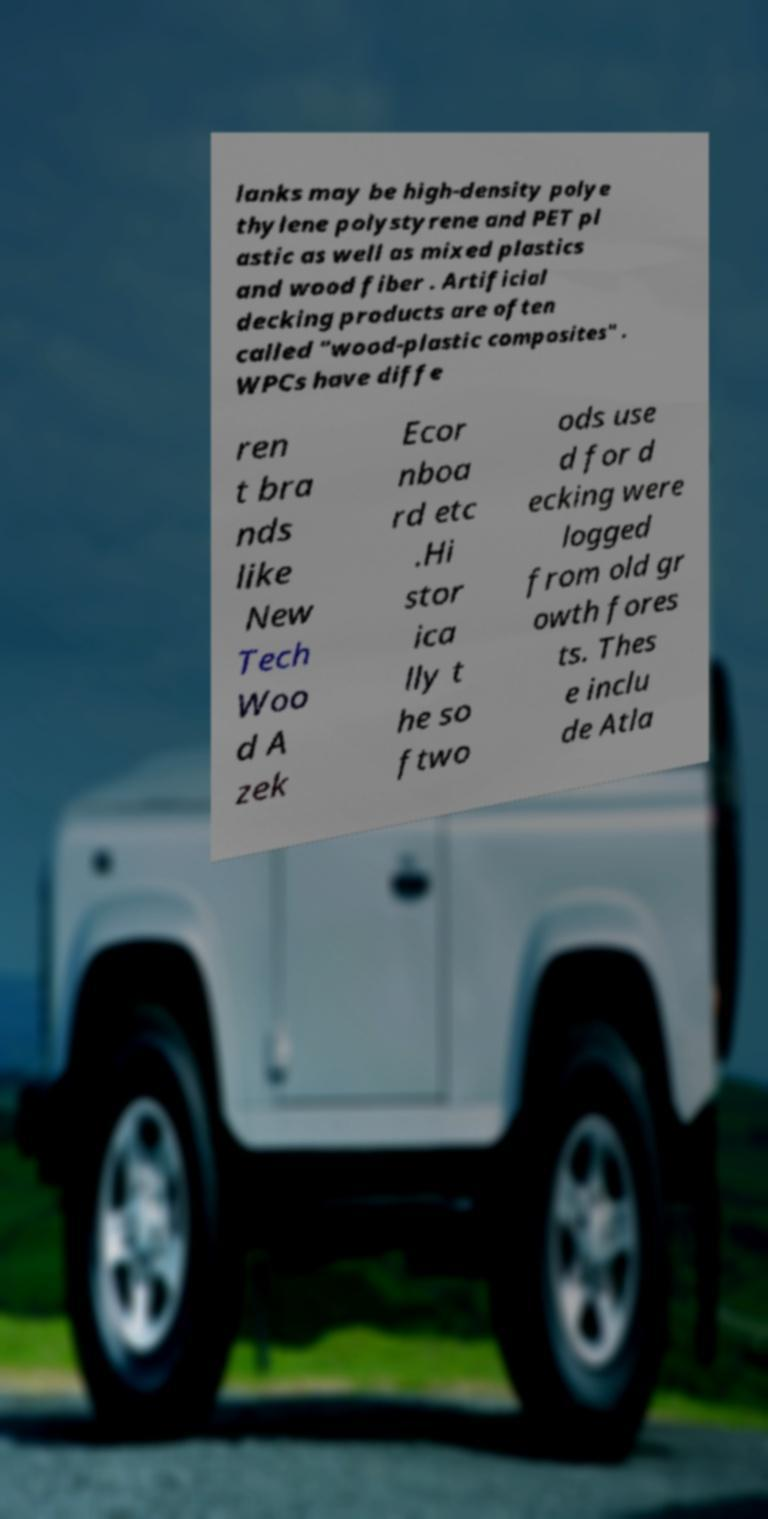Could you assist in decoding the text presented in this image and type it out clearly? lanks may be high-density polye thylene polystyrene and PET pl astic as well as mixed plastics and wood fiber . Artificial decking products are often called "wood-plastic composites" . WPCs have diffe ren t bra nds like New Tech Woo d A zek Ecor nboa rd etc .Hi stor ica lly t he so ftwo ods use d for d ecking were logged from old gr owth fores ts. Thes e inclu de Atla 